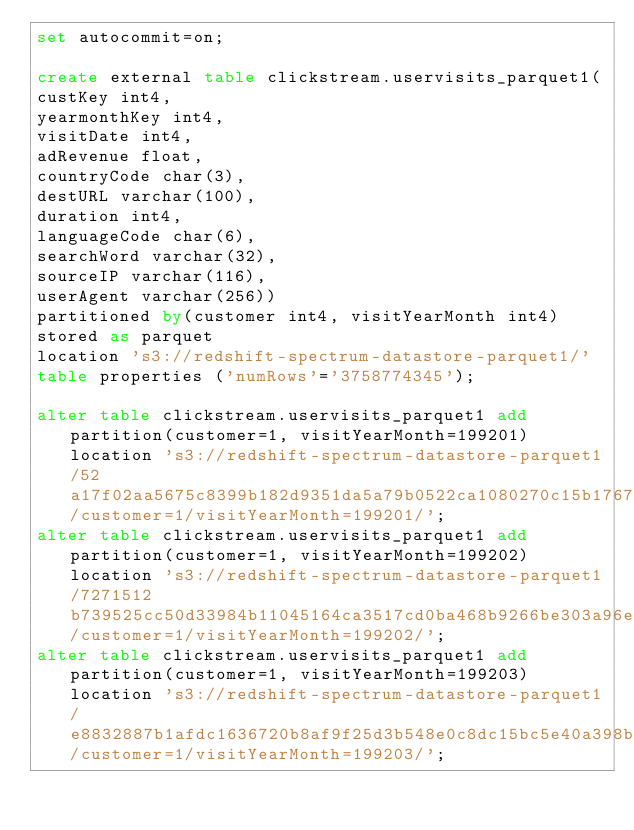Convert code to text. <code><loc_0><loc_0><loc_500><loc_500><_SQL_>set autocommit=on;

create external table clickstream.uservisits_parquet1(
custKey int4,
yearmonthKey int4,
visitDate int4,
adRevenue float,
countryCode char(3),
destURL varchar(100),
duration int4,
languageCode char(6),
searchWord varchar(32),
sourceIP varchar(116),
userAgent varchar(256))
partitioned by(customer int4, visitYearMonth int4)
stored as parquet
location 's3://redshift-spectrum-datastore-parquet1/'
table properties ('numRows'='3758774345');

alter table clickstream.uservisits_parquet1 add partition(customer=1, visitYearMonth=199201) location 's3://redshift-spectrum-datastore-parquet1/52a17f02aa5675c8399b182d9351da5a79b0522ca1080270c15b1767031babf4/customer=1/visitYearMonth=199201/';
alter table clickstream.uservisits_parquet1 add partition(customer=1, visitYearMonth=199202) location 's3://redshift-spectrum-datastore-parquet1/7271512b739525cc50d33984b11045164ca3517cd0ba468b9266be303a96eead/customer=1/visitYearMonth=199202/';
alter table clickstream.uservisits_parquet1 add partition(customer=1, visitYearMonth=199203) location 's3://redshift-spectrum-datastore-parquet1/e8832887b1afdc1636720b8af9f25d3b548e0c8dc15bc5e40a398b338a0c2134/customer=1/visitYearMonth=199203/';</code> 